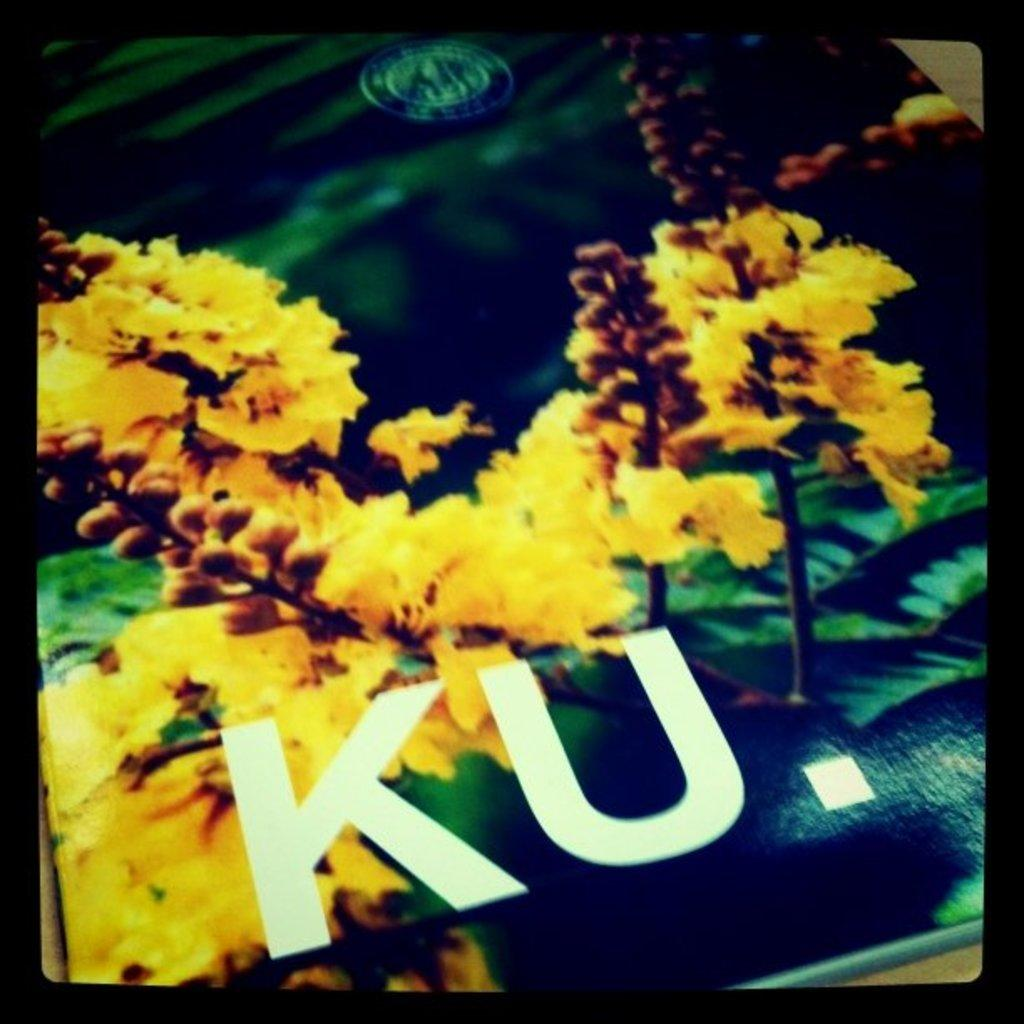What type of living organisms can be seen in the image? There are flowers in the image. What else is present in the image besides the flowers? There is text in the image. How many cats are wearing mittens in the image? There are no cats or mittens present in the image. What holiday is being celebrated in the image? There is no indication of a holiday being celebrated in the image. 